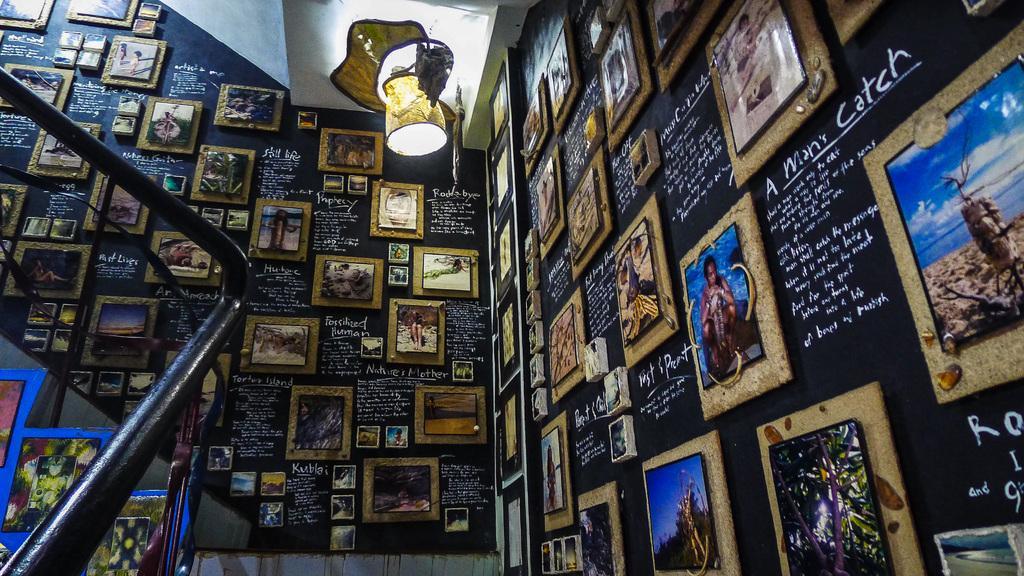How would you summarize this image in a sentence or two? In this image I can see many frames attached to the wall and I can see something written on the wall. In the background I can see the light, few stairs and poles. 